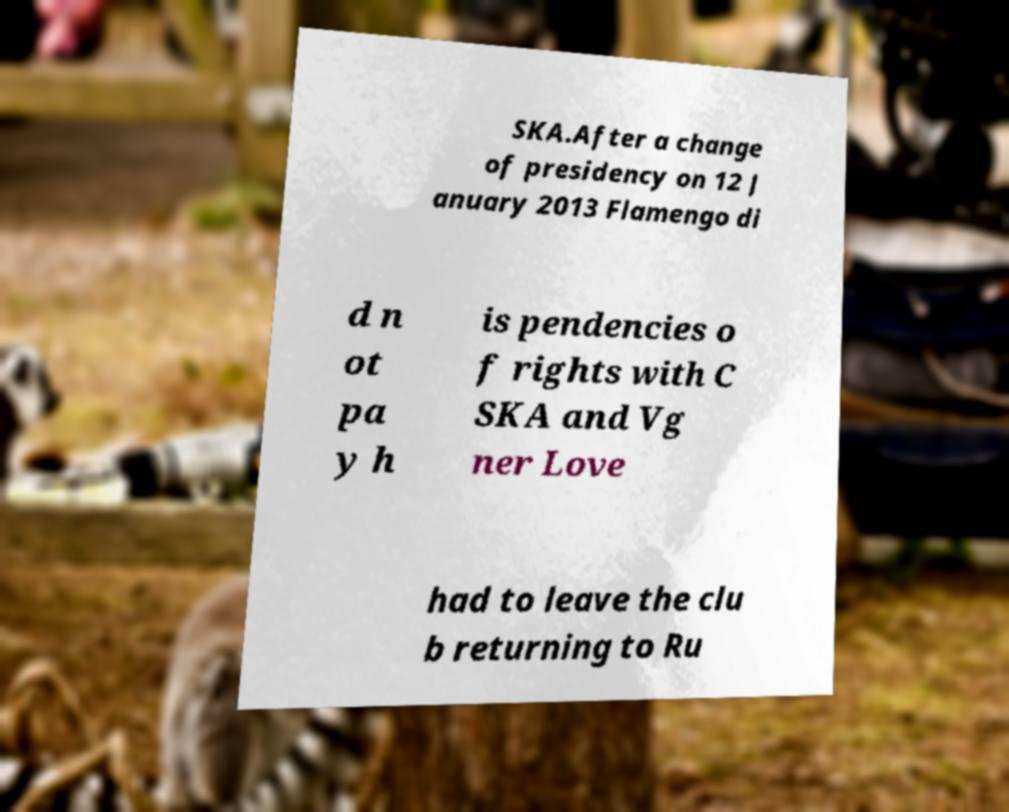Please identify and transcribe the text found in this image. SKA.After a change of presidency on 12 J anuary 2013 Flamengo di d n ot pa y h is pendencies o f rights with C SKA and Vg ner Love had to leave the clu b returning to Ru 